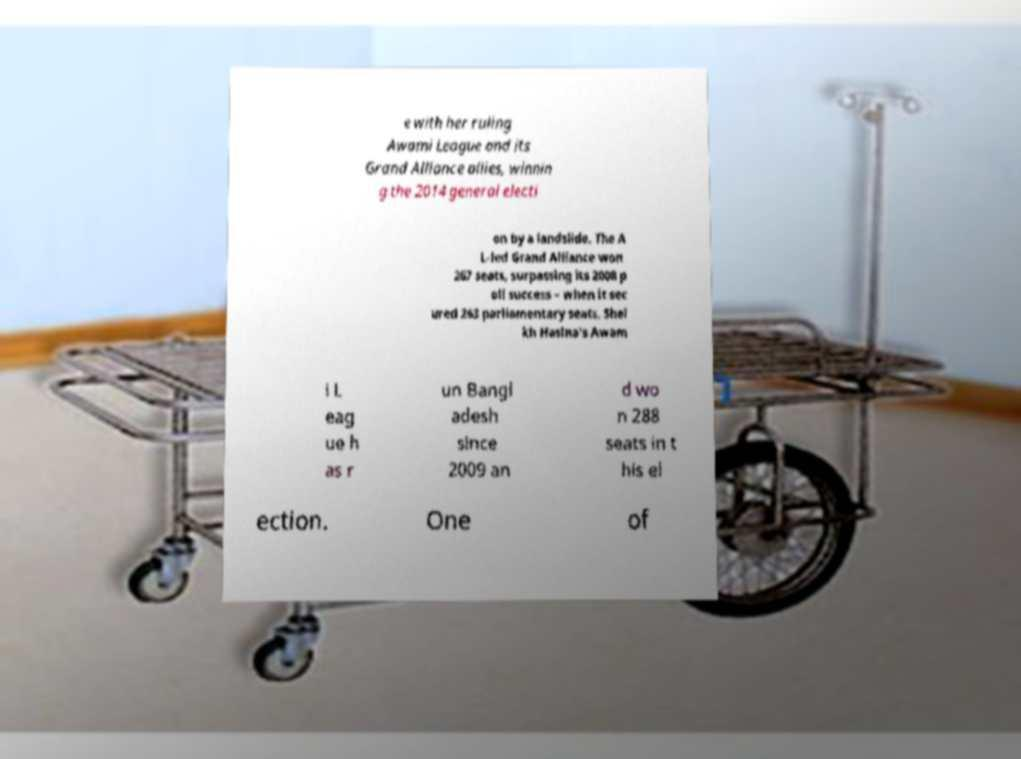Could you extract and type out the text from this image? e with her ruling Awami League and its Grand Alliance allies, winnin g the 2014 general electi on by a landslide. The A L-led Grand Alliance won 267 seats, surpassing its 2008 p oll success – when it sec ured 263 parliamentary seats. Shei kh Hasina's Awam i L eag ue h as r un Bangl adesh since 2009 an d wo n 288 seats in t his el ection. One of 